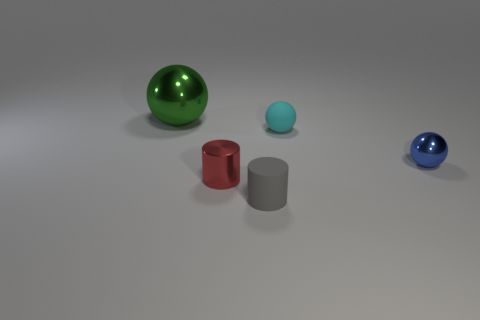Add 3 small objects. How many objects exist? 8 Subtract all cylinders. How many objects are left? 3 Add 4 metallic things. How many metallic things exist? 7 Subtract 0 yellow cylinders. How many objects are left? 5 Subtract all red spheres. Subtract all small red objects. How many objects are left? 4 Add 3 big metal objects. How many big metal objects are left? 4 